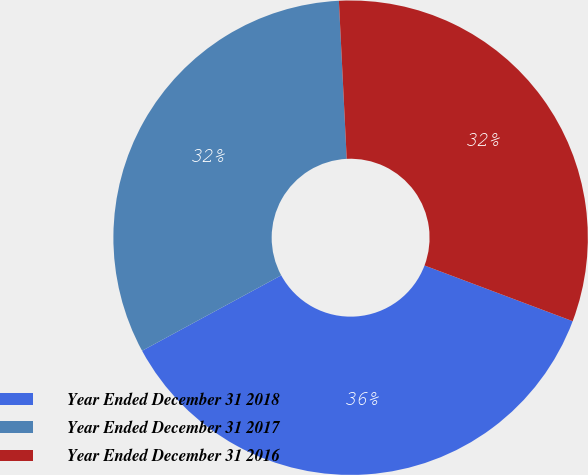<chart> <loc_0><loc_0><loc_500><loc_500><pie_chart><fcel>Year Ended December 31 2018<fcel>Year Ended December 31 2017<fcel>Year Ended December 31 2016<nl><fcel>36.37%<fcel>32.12%<fcel>31.51%<nl></chart> 